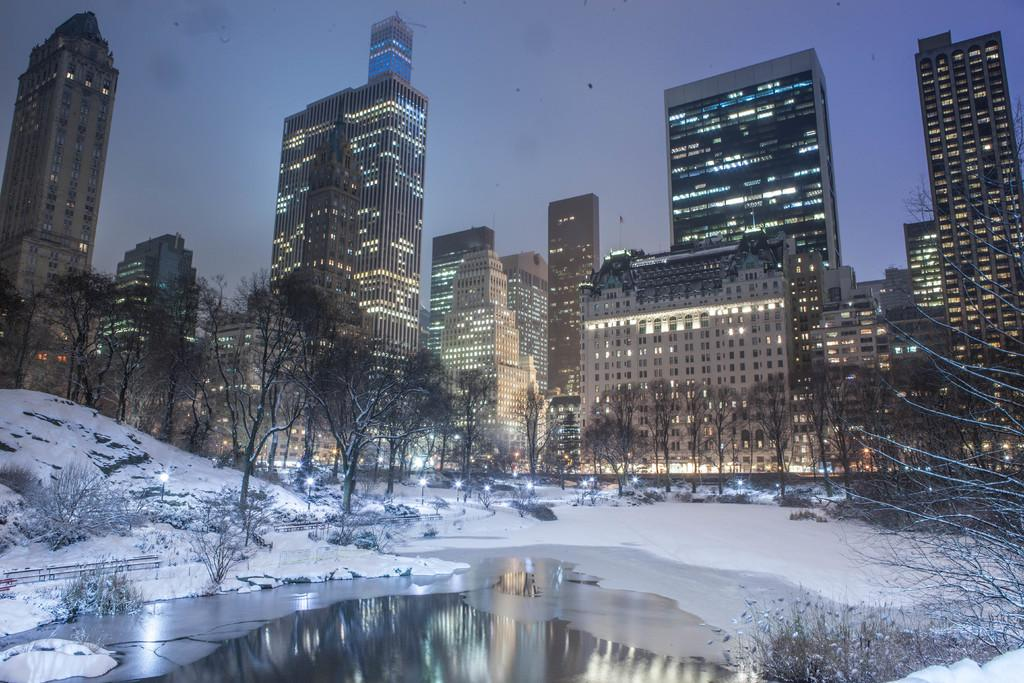What type of structures can be seen in the image? There are buildings in the image. What natural elements are present in the image? There are trees and plants in the image. What is the weather like in the image? There is snow visible in the image, indicating a cold or wintery environment. What else can be seen in the image besides buildings and plants? There is water visible in the image. What is visible in the background of the image? The sky is visible in the background of the image. Where is the brain located in the image? There is no brain present in the image. What type of seat can be seen in the image? There is no seat present in the image. 